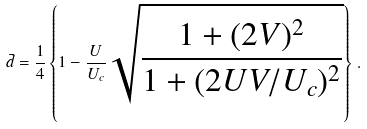Convert formula to latex. <formula><loc_0><loc_0><loc_500><loc_500>\bar { d } = \frac { 1 } { 4 } \left \{ 1 - \frac { U } { U _ { c } } \sqrt { \frac { 1 + ( 2 V ) ^ { 2 } } { 1 + ( 2 U V / U _ { c } ) ^ { 2 } } } \right \} \, .</formula> 